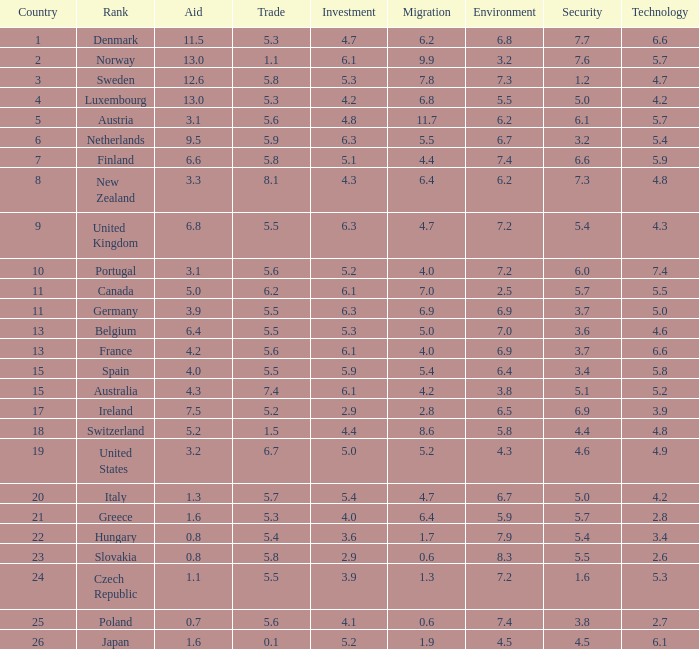What is the migration rating when trade is 5.7? 4.7. 